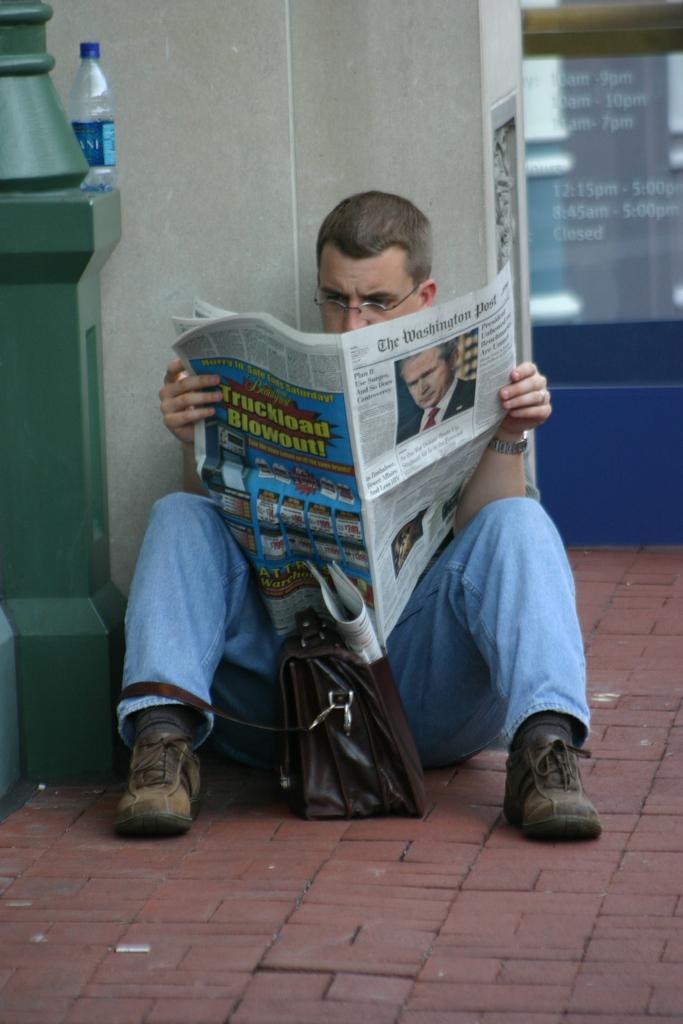Can you describe this image briefly? In this image, we can see a person is sitting on the floor and holding a newspaper. He is reading a newspaper. Background we can see a wall. Left side of the image, we can see a pillar with bottle. Right side of the image, we can see a screen. Here a bag is there on the floor. 